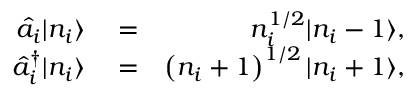<formula> <loc_0><loc_0><loc_500><loc_500>\begin{array} { r l r } { \hat { a } _ { i } | n _ { i } \rangle } & = } & { n _ { i } ^ { 1 / 2 } | n _ { i } - 1 \rangle , } \\ { \hat { a } _ { i } ^ { \dagger } | n _ { i } \rangle } & = } & { \left ( n _ { i } + 1 \right ) ^ { 1 / 2 } | n _ { i } + 1 \rangle , } \end{array}</formula> 